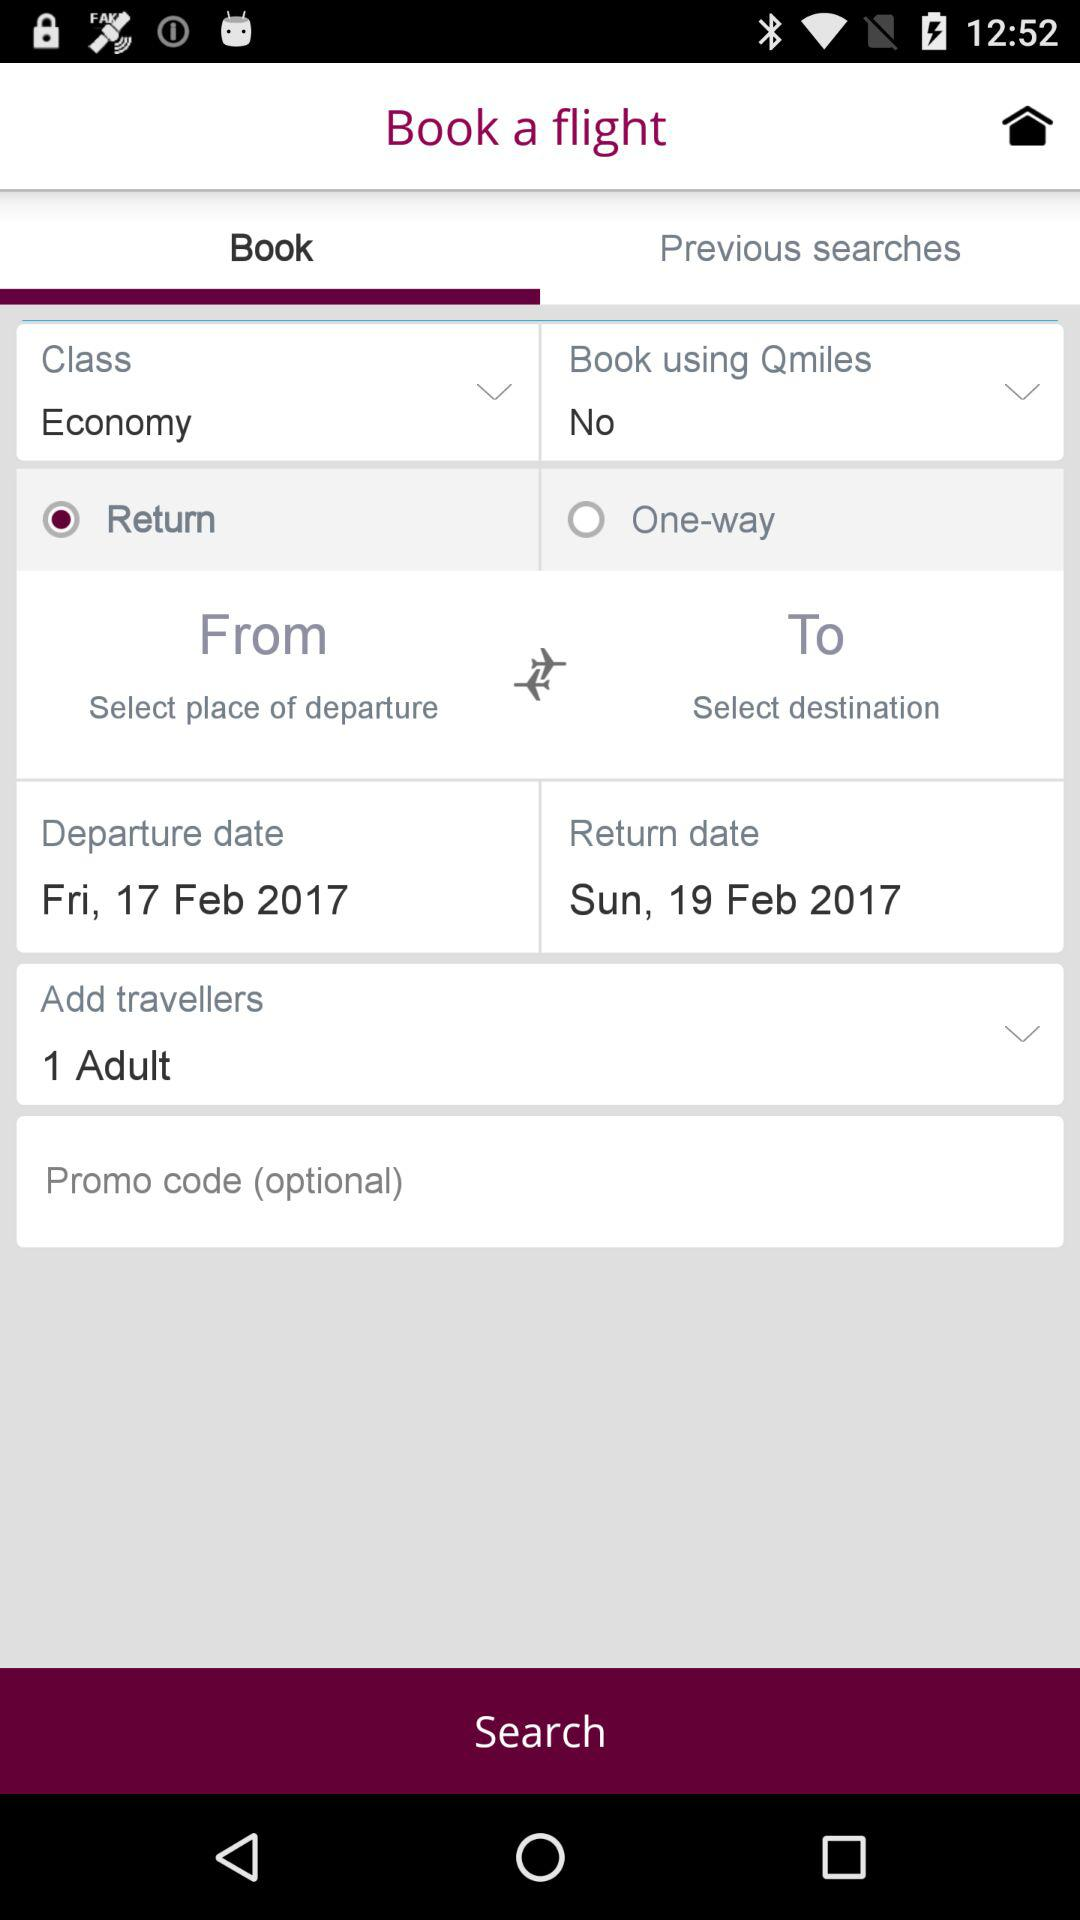What is the setting for "Book using Qmiles"? The setting is "No". 